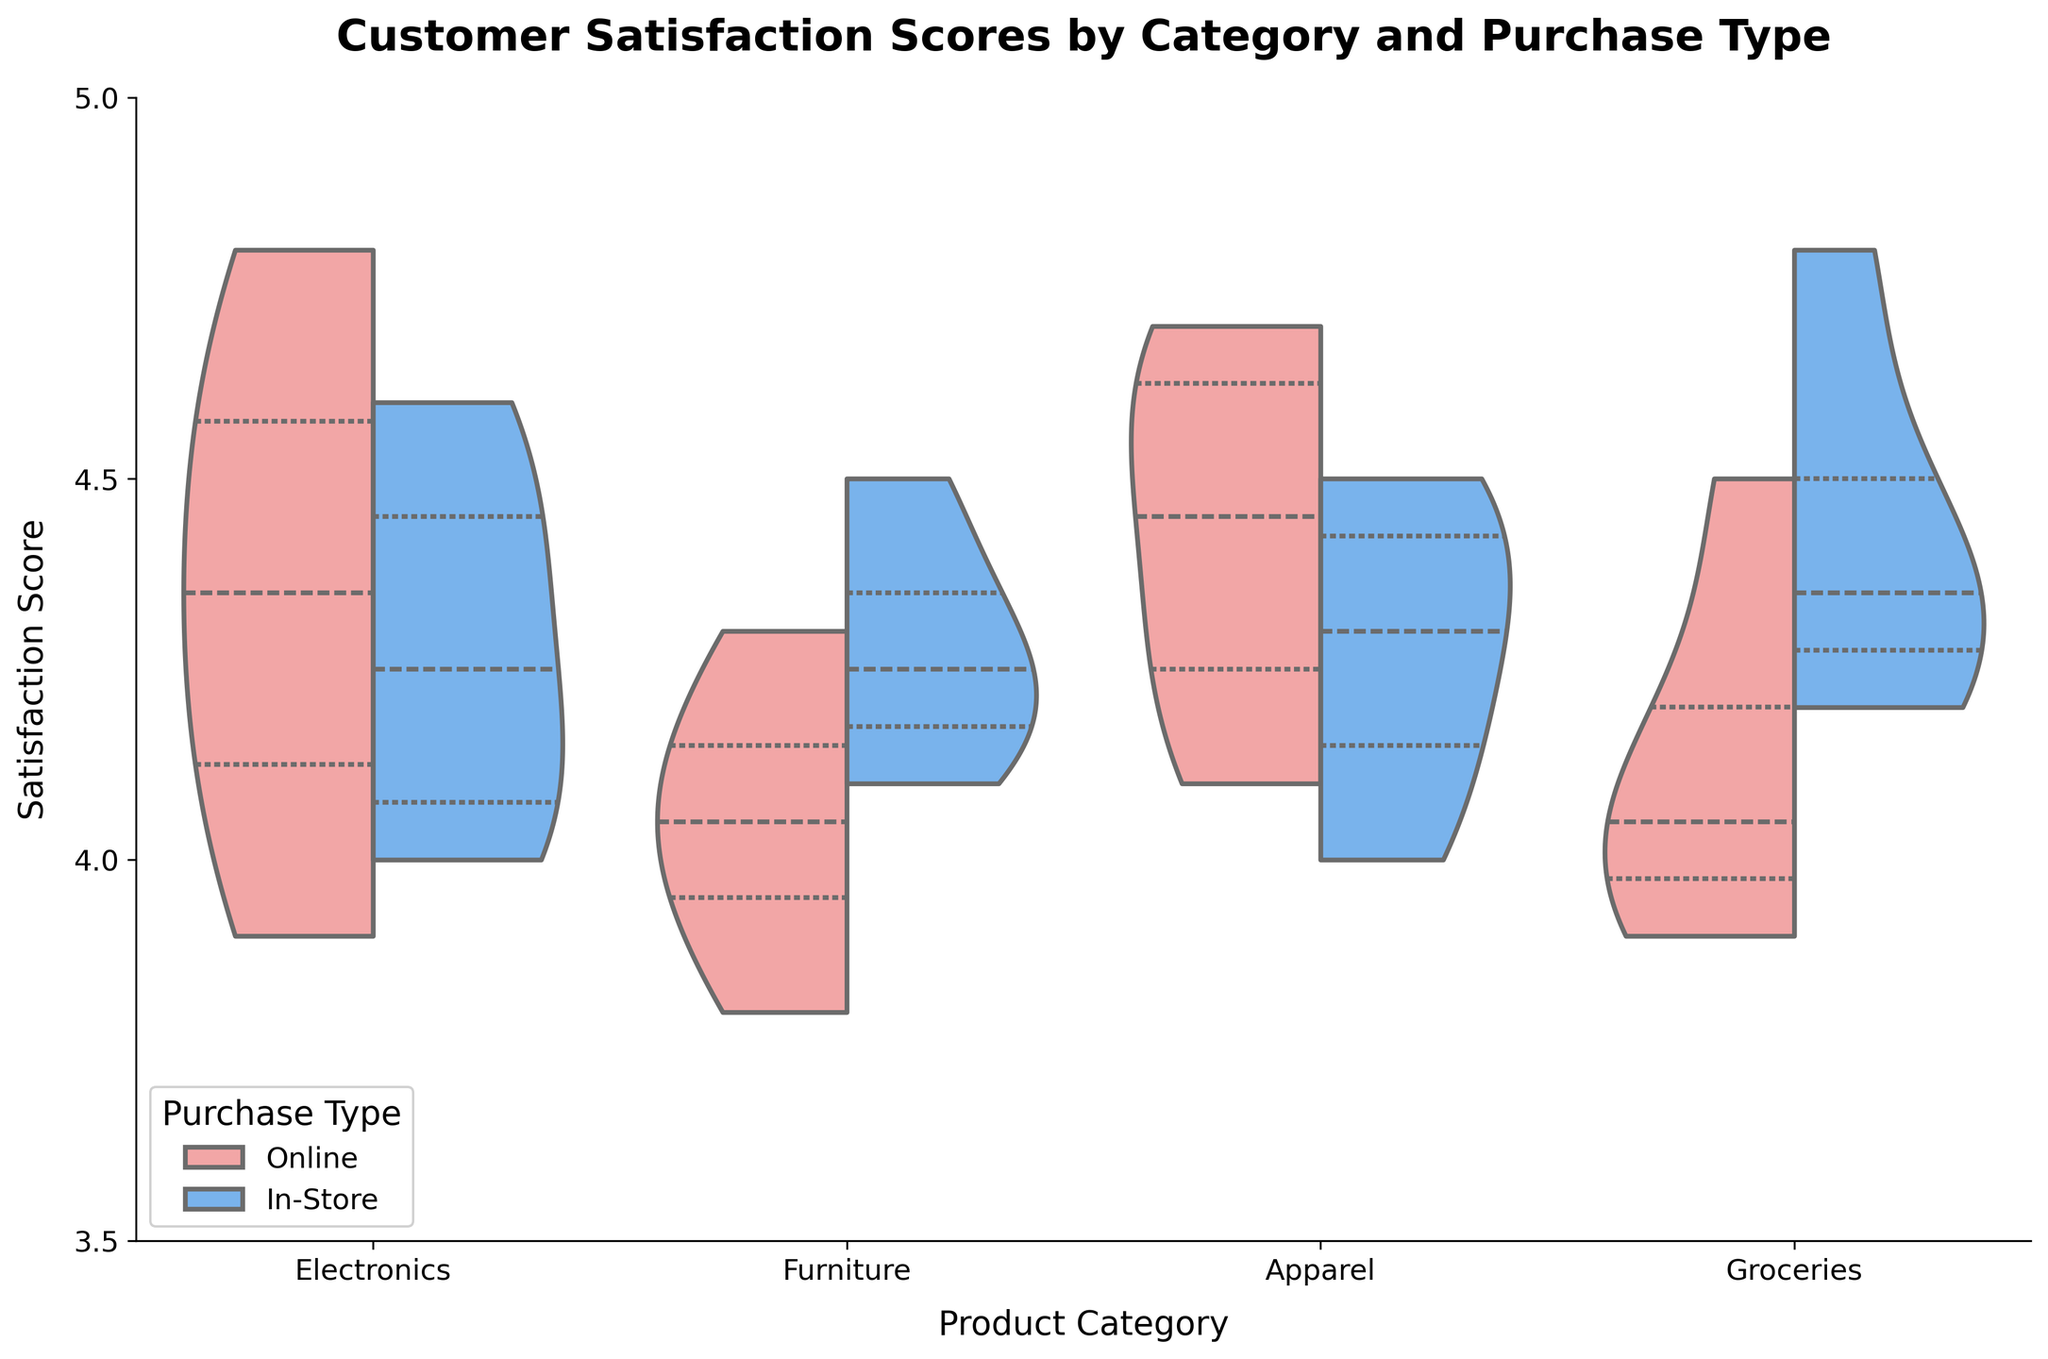What is the title of the plot? The title is displayed at the top of the plot in bold font. It provides the overall context for what the chart illustrates.
Answer: Customer Satisfaction Scores by Category and Purchase Type How many product categories are shown in the plot? The x-axis labels display the different product categories represented in the chart. Count the unique labels to determine the number of product categories.
Answer: 4 What is the y-axis range for the satisfaction scores? Look at the numerical values indicated along the y-axis. The lowest value should be the starting point of the range, and the highest value should be the endpoint.
Answer: 3.5 to 5.0 Which category has the highest in-store satisfaction score median? Identify the median lines (inner quartiles) for the in-store purchase type within each category. Compare the position of these lines along the y-axis to determine which is the highest.
Answer: Groceries What color represents the online purchase type? Refer to the legend in the plot, which matches the colors used with their respective purchase types.
Answer: Light Pink How do the distributions of satisfaction scores for online and in-store purchases in the Electronics category compare? Examine the shapes, spread, and positioning of the split violins for the Electronics category. Compare the in-store and online distributions in terms of width and central tendency.
Answer: The in-store distribution is slightly more concentrated around 4.0–4.6, while the online distribution shows a wider spread from 3.9 to 4.8 Which product category appears to have the least variability in satisfaction scores for both online and in-store purchases? Look for the narrowest violins in terms of width, representing a smaller spread of scores. Compare across categories for both purchase types.
Answer: Apparel Is the median satisfaction score higher for online or in-store purchases in the Furniture category? Identify the median lines (inner quartiles) within the split violins for the Furniture category and compare their positions vertically.
Answer: In-store How does the median satisfaction score for online Electronics compare to online Furniture? Find the median lines indicated within each split violin for the online purchase type in both categories. Compare the y-axis positions of these lines.
Answer: The median for Electronics is slightly higher than for Furniture Are there any categories where the satisfaction scores for online purchases are more variable than for in-store purchases? Look for wider violins representing online purchases. Compare these to their in-store counterparts within each category to note any significant differences in spread.
Answer: Groceries and Apparel 